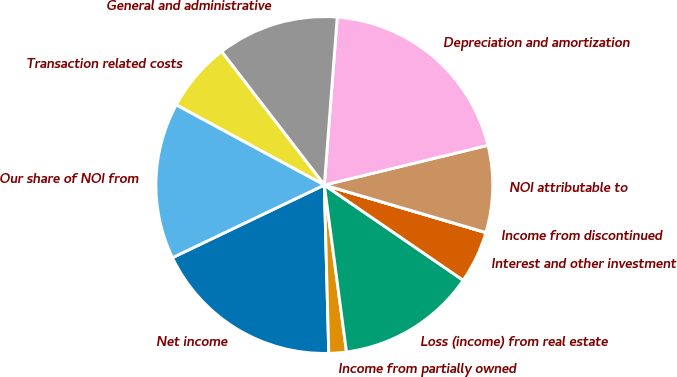Convert chart. <chart><loc_0><loc_0><loc_500><loc_500><pie_chart><fcel>Net income<fcel>Income from partially owned<fcel>Loss (income) from real estate<fcel>Interest and other investment<fcel>Income from discontinued<fcel>NOI attributable to<fcel>Depreciation and amortization<fcel>General and administrative<fcel>Transaction related costs<fcel>Our share of NOI from<nl><fcel>18.32%<fcel>1.68%<fcel>13.33%<fcel>5.01%<fcel>0.01%<fcel>8.34%<fcel>19.99%<fcel>11.66%<fcel>6.67%<fcel>14.99%<nl></chart> 